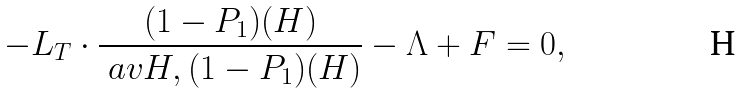<formula> <loc_0><loc_0><loc_500><loc_500>- L _ { T } \cdot \frac { ( 1 - P _ { 1 } ) ( H ) } { \ a v { H , ( 1 - P _ { 1 } ) ( H ) } } - \Lambda + F = 0 ,</formula> 